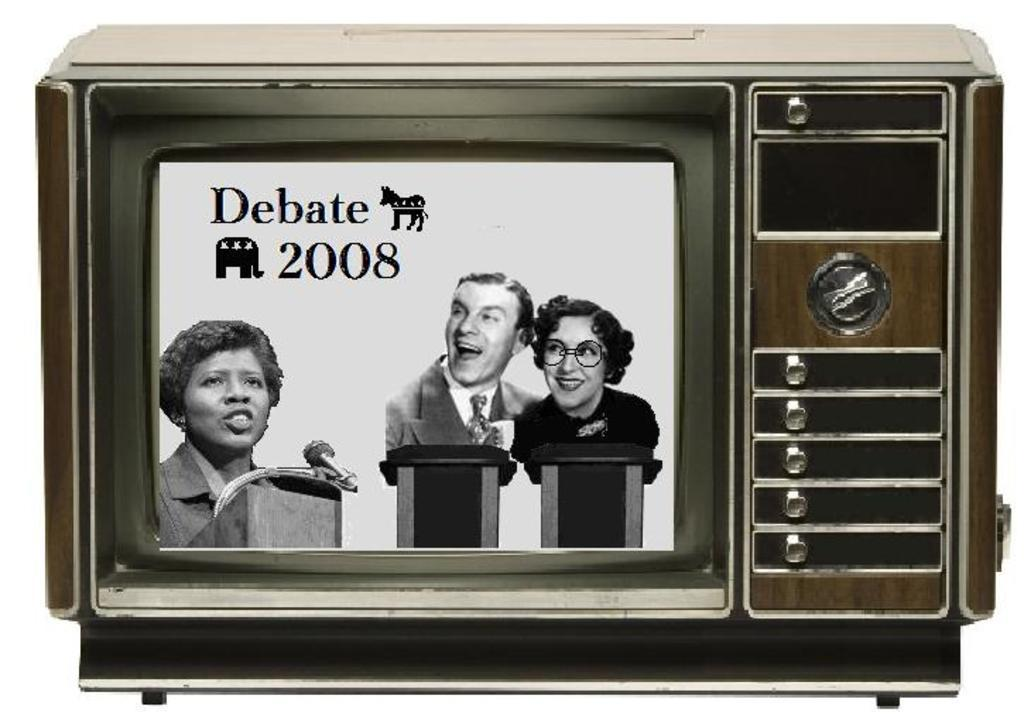<image>
Describe the image concisely. An old retro television showing the 2008 Debate. 